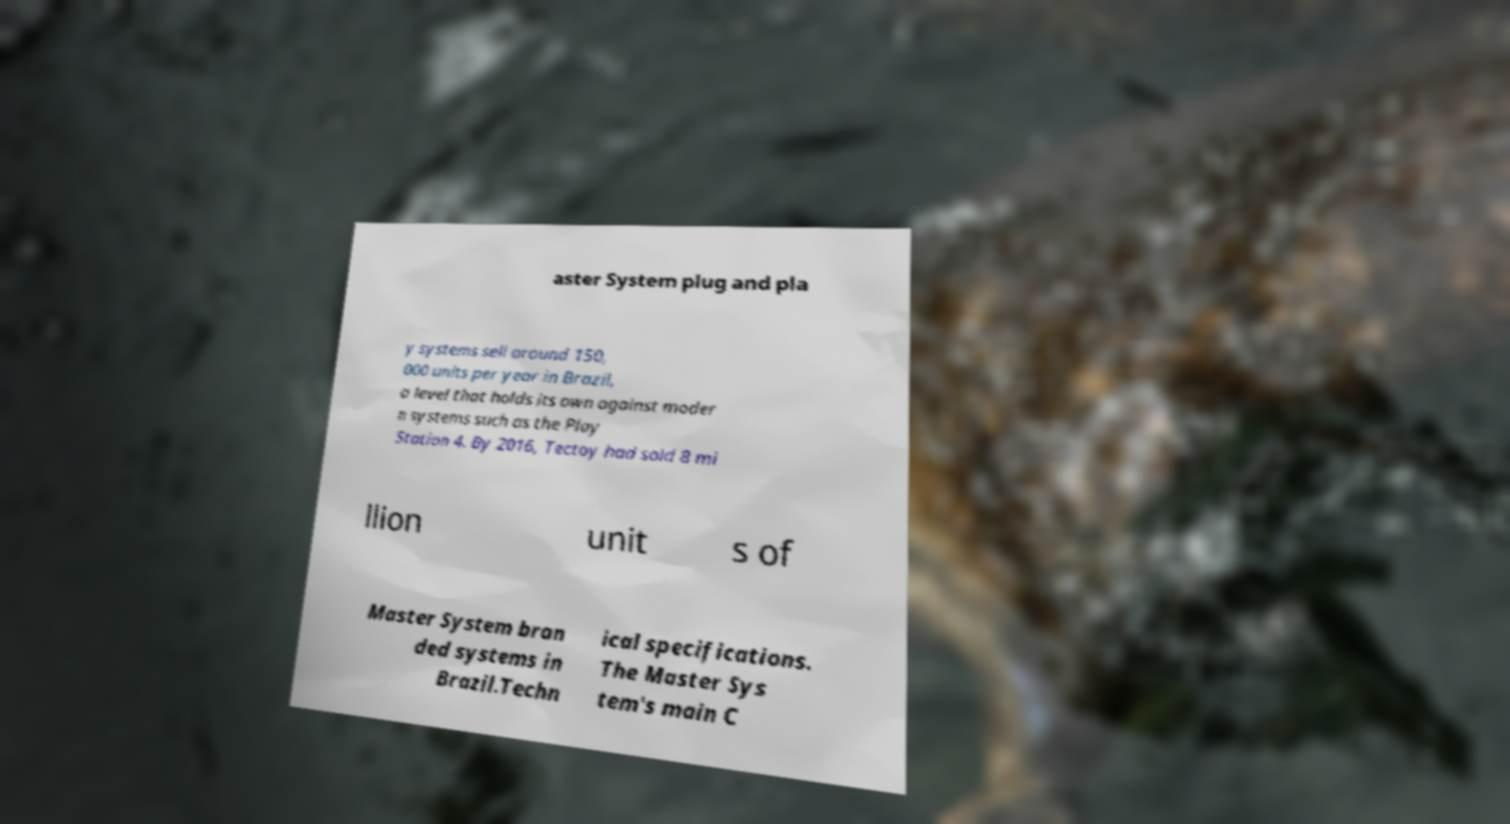What messages or text are displayed in this image? I need them in a readable, typed format. aster System plug and pla y systems sell around 150, 000 units per year in Brazil, a level that holds its own against moder n systems such as the Play Station 4. By 2016, Tectoy had sold 8 mi llion unit s of Master System bran ded systems in Brazil.Techn ical specifications. The Master Sys tem's main C 